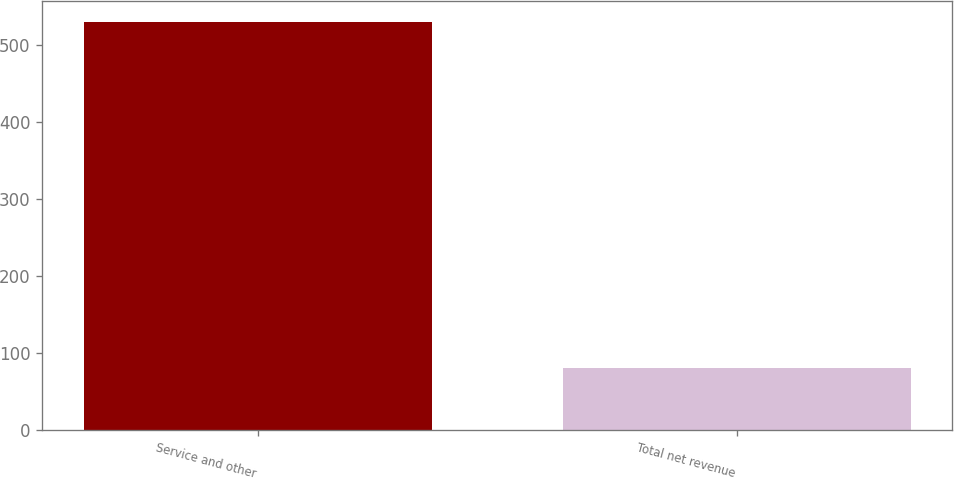<chart> <loc_0><loc_0><loc_500><loc_500><bar_chart><fcel>Service and other<fcel>Total net revenue<nl><fcel>530<fcel>81<nl></chart> 